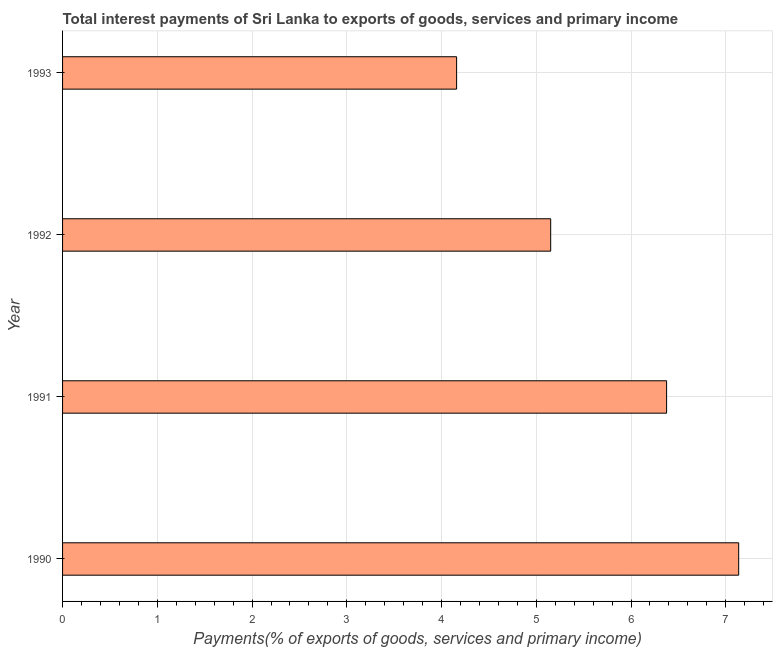Does the graph contain grids?
Keep it short and to the point. Yes. What is the title of the graph?
Your answer should be very brief. Total interest payments of Sri Lanka to exports of goods, services and primary income. What is the label or title of the X-axis?
Give a very brief answer. Payments(% of exports of goods, services and primary income). What is the label or title of the Y-axis?
Offer a very short reply. Year. What is the total interest payments on external debt in 1991?
Offer a terse response. 6.38. Across all years, what is the maximum total interest payments on external debt?
Provide a short and direct response. 7.14. Across all years, what is the minimum total interest payments on external debt?
Make the answer very short. 4.16. What is the sum of the total interest payments on external debt?
Your response must be concise. 22.82. What is the difference between the total interest payments on external debt in 1991 and 1992?
Provide a short and direct response. 1.22. What is the average total interest payments on external debt per year?
Keep it short and to the point. 5.71. What is the median total interest payments on external debt?
Make the answer very short. 5.76. What is the ratio of the total interest payments on external debt in 1990 to that in 1992?
Keep it short and to the point. 1.39. Is the difference between the total interest payments on external debt in 1990 and 1991 greater than the difference between any two years?
Make the answer very short. No. What is the difference between the highest and the second highest total interest payments on external debt?
Make the answer very short. 0.76. What is the difference between the highest and the lowest total interest payments on external debt?
Offer a very short reply. 2.98. In how many years, is the total interest payments on external debt greater than the average total interest payments on external debt taken over all years?
Keep it short and to the point. 2. How many years are there in the graph?
Provide a succinct answer. 4. What is the difference between two consecutive major ticks on the X-axis?
Your response must be concise. 1. What is the Payments(% of exports of goods, services and primary income) in 1990?
Your answer should be compact. 7.14. What is the Payments(% of exports of goods, services and primary income) of 1991?
Keep it short and to the point. 6.38. What is the Payments(% of exports of goods, services and primary income) in 1992?
Offer a terse response. 5.15. What is the Payments(% of exports of goods, services and primary income) of 1993?
Provide a succinct answer. 4.16. What is the difference between the Payments(% of exports of goods, services and primary income) in 1990 and 1991?
Give a very brief answer. 0.76. What is the difference between the Payments(% of exports of goods, services and primary income) in 1990 and 1992?
Provide a succinct answer. 1.98. What is the difference between the Payments(% of exports of goods, services and primary income) in 1990 and 1993?
Provide a short and direct response. 2.98. What is the difference between the Payments(% of exports of goods, services and primary income) in 1991 and 1992?
Your response must be concise. 1.22. What is the difference between the Payments(% of exports of goods, services and primary income) in 1991 and 1993?
Provide a succinct answer. 2.22. What is the difference between the Payments(% of exports of goods, services and primary income) in 1992 and 1993?
Offer a terse response. 0.99. What is the ratio of the Payments(% of exports of goods, services and primary income) in 1990 to that in 1991?
Provide a succinct answer. 1.12. What is the ratio of the Payments(% of exports of goods, services and primary income) in 1990 to that in 1992?
Your answer should be compact. 1.39. What is the ratio of the Payments(% of exports of goods, services and primary income) in 1990 to that in 1993?
Ensure brevity in your answer.  1.72. What is the ratio of the Payments(% of exports of goods, services and primary income) in 1991 to that in 1992?
Offer a very short reply. 1.24. What is the ratio of the Payments(% of exports of goods, services and primary income) in 1991 to that in 1993?
Ensure brevity in your answer.  1.53. What is the ratio of the Payments(% of exports of goods, services and primary income) in 1992 to that in 1993?
Keep it short and to the point. 1.24. 